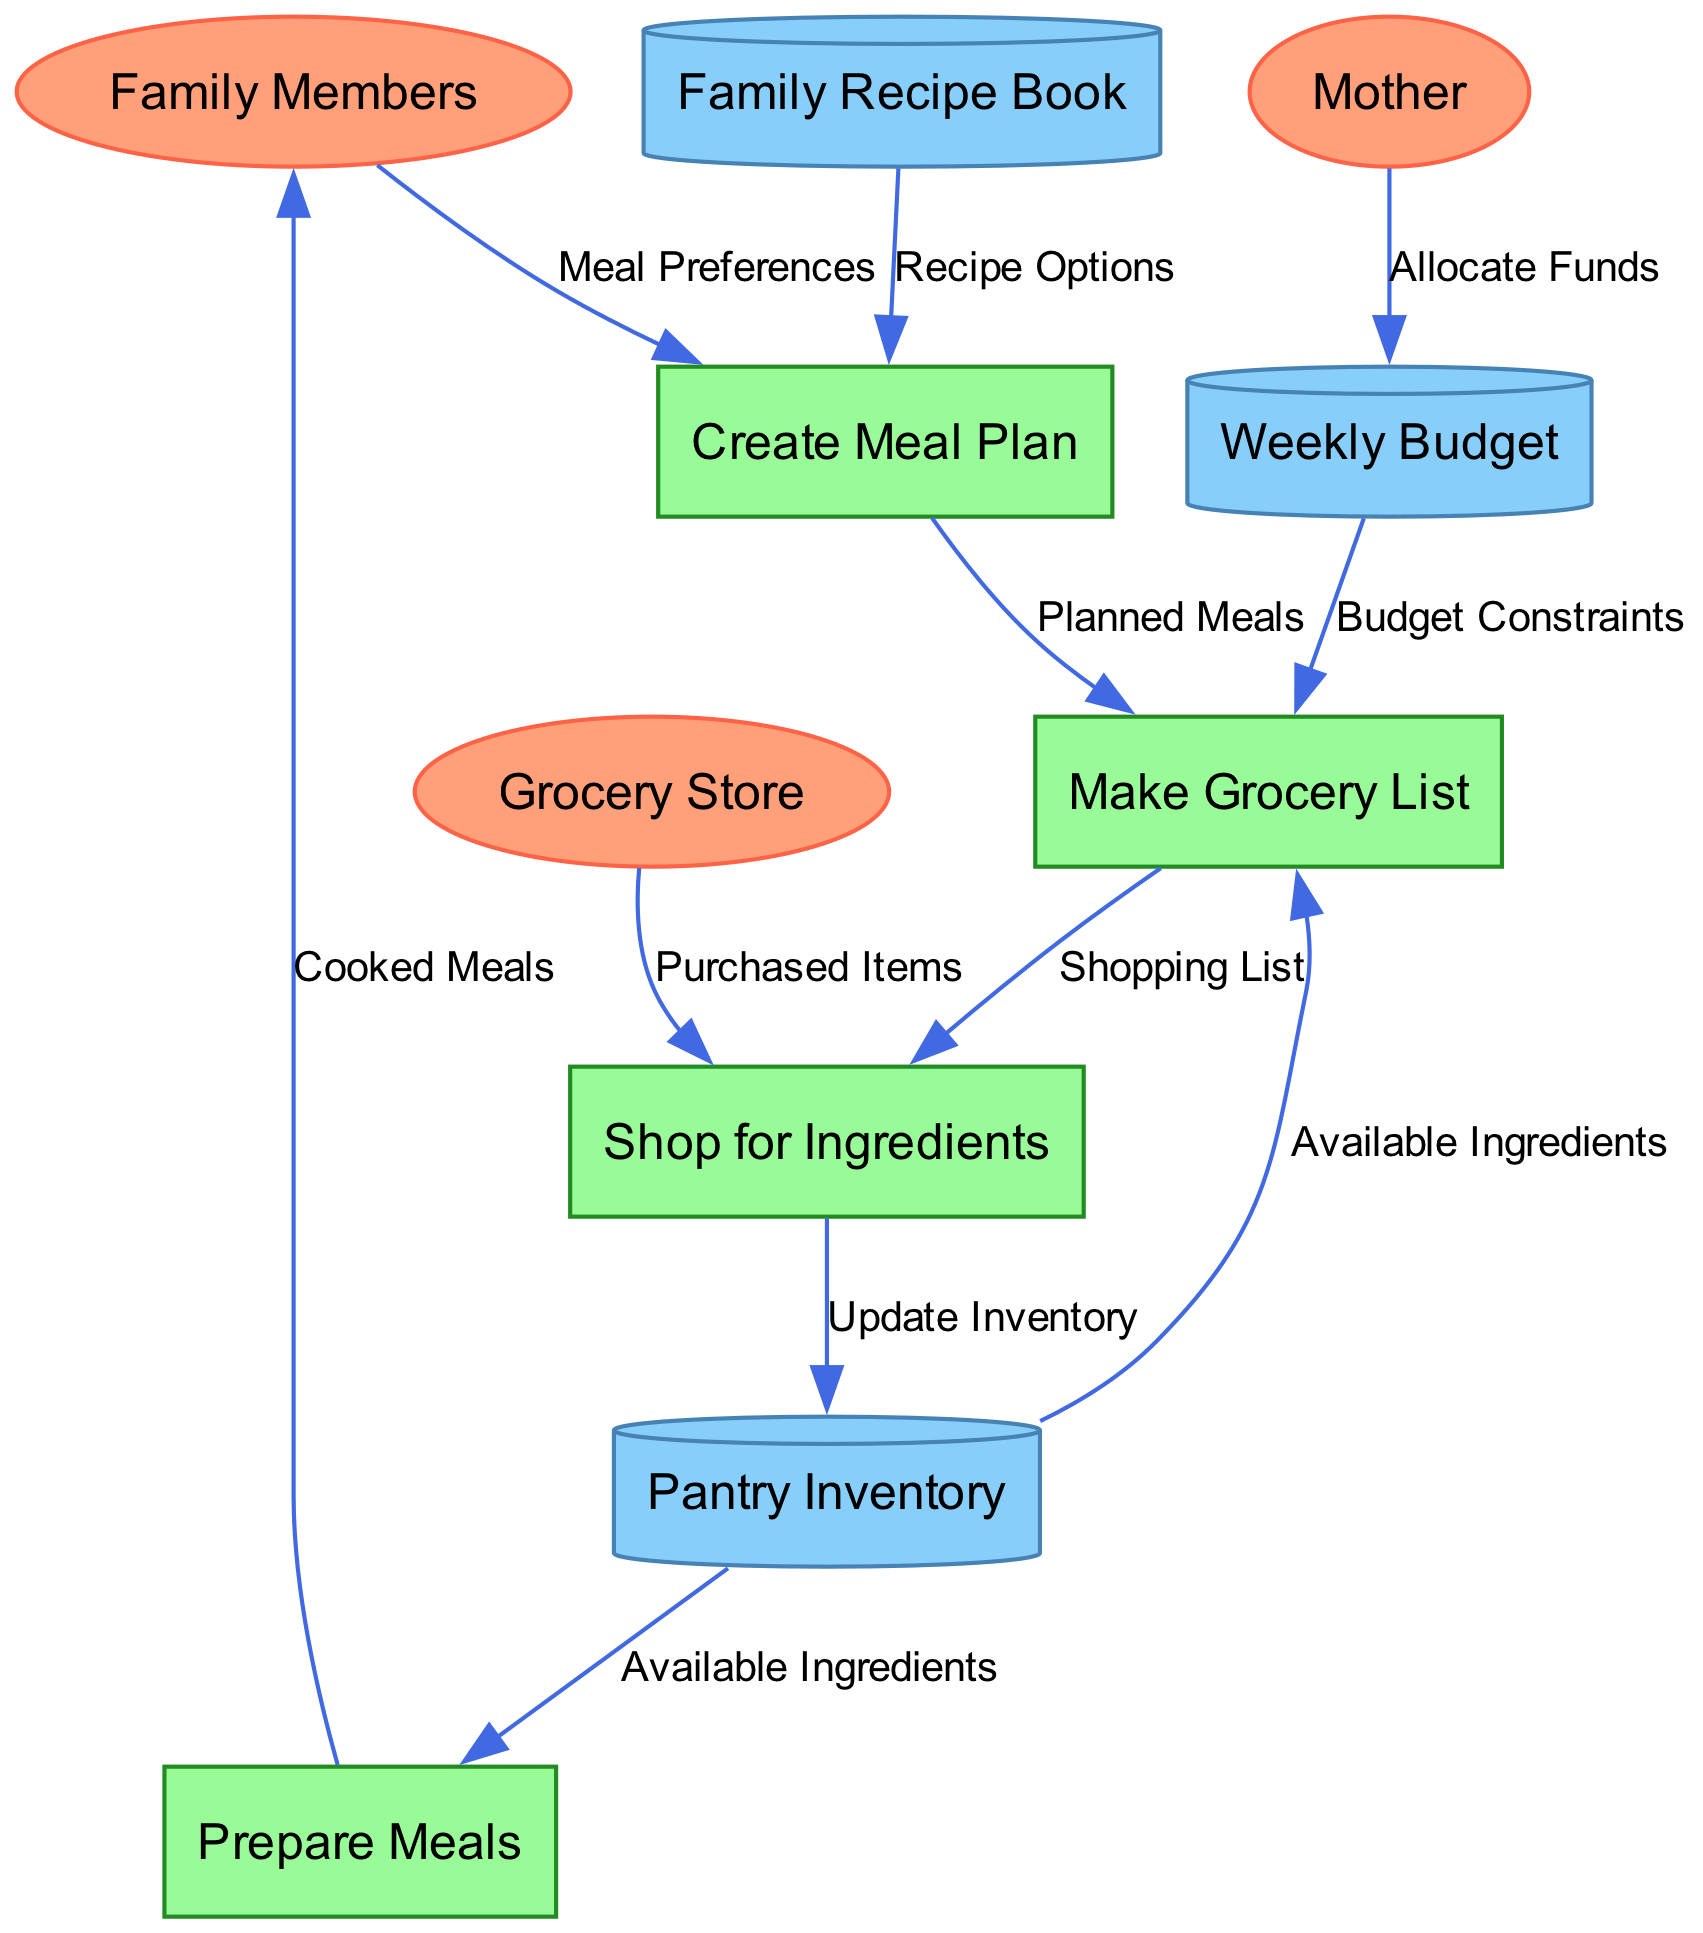What are the external entities in the diagram? The external entities in the diagram are "Family Members," "Grocery Store," and "Mother." Each of these represents an external source or destination of data within the meal planning and grocery shopping workflow.
Answer: Family Members, Grocery Store, Mother How many processes are there in the diagram? There are four processes in the diagram: "Create Meal Plan," "Make Grocery List," "Shop for Ingredients," and "Prepare Meals." The question looks for a count of the processes represented in the diagram.
Answer: 4 Which process receives the "Meal Preferences"? The "Create Meal Plan" process receives the "Meal Preferences." This indicates that family members provide their meal preferences to this particular process for consideration in meal planning.
Answer: Create Meal Plan What is the relationship between "Weekly Budget" and "Make Grocery List"? The "Weekly Budget" provides "Budget Constraints" to the "Make Grocery List" process. This shows that the budget affects the grocery list creation, ensuring spending stays within limits.
Answer: Budget Constraints What data source provides "Available Ingredients" to "Prepare Meals"? The "Pantry Inventory" provides "Available Ingredients" to the "Prepare Meals" process. This means that before meals are prepared, the available items from the pantry are considered.
Answer: Pantry Inventory Which external entity allocates funds? The "Mother" is the external entity that allocates funds to the "Weekly Budget." This indicates her responsibility in managing the finances for meal planning and grocery shopping.
Answer: Mother What is produced by the "Prepare Meals" process? The "Prepare Meals" process produces "Cooked Meals" that are delivered to "Family Members." This highlights the final outcome of the meal preparation activity.
Answer: Cooked Meals Describe the flow of data from "Make Grocery List" to "Shop for Ingredients." The "Make Grocery List" process outputs the "Shopping List" to the "Shop for Ingredients" process. This shows that the grocery list directly informs the shopping activity at the store.
Answer: Shopping List How does the "Grocery Store" fit into the workflow? The "Grocery Store" provides "Purchased Items" to the "Shop for Ingredients" process. This establishes the grocery store as a key location where ingredients are bought based on the shopping list.
Answer: Purchased Items 